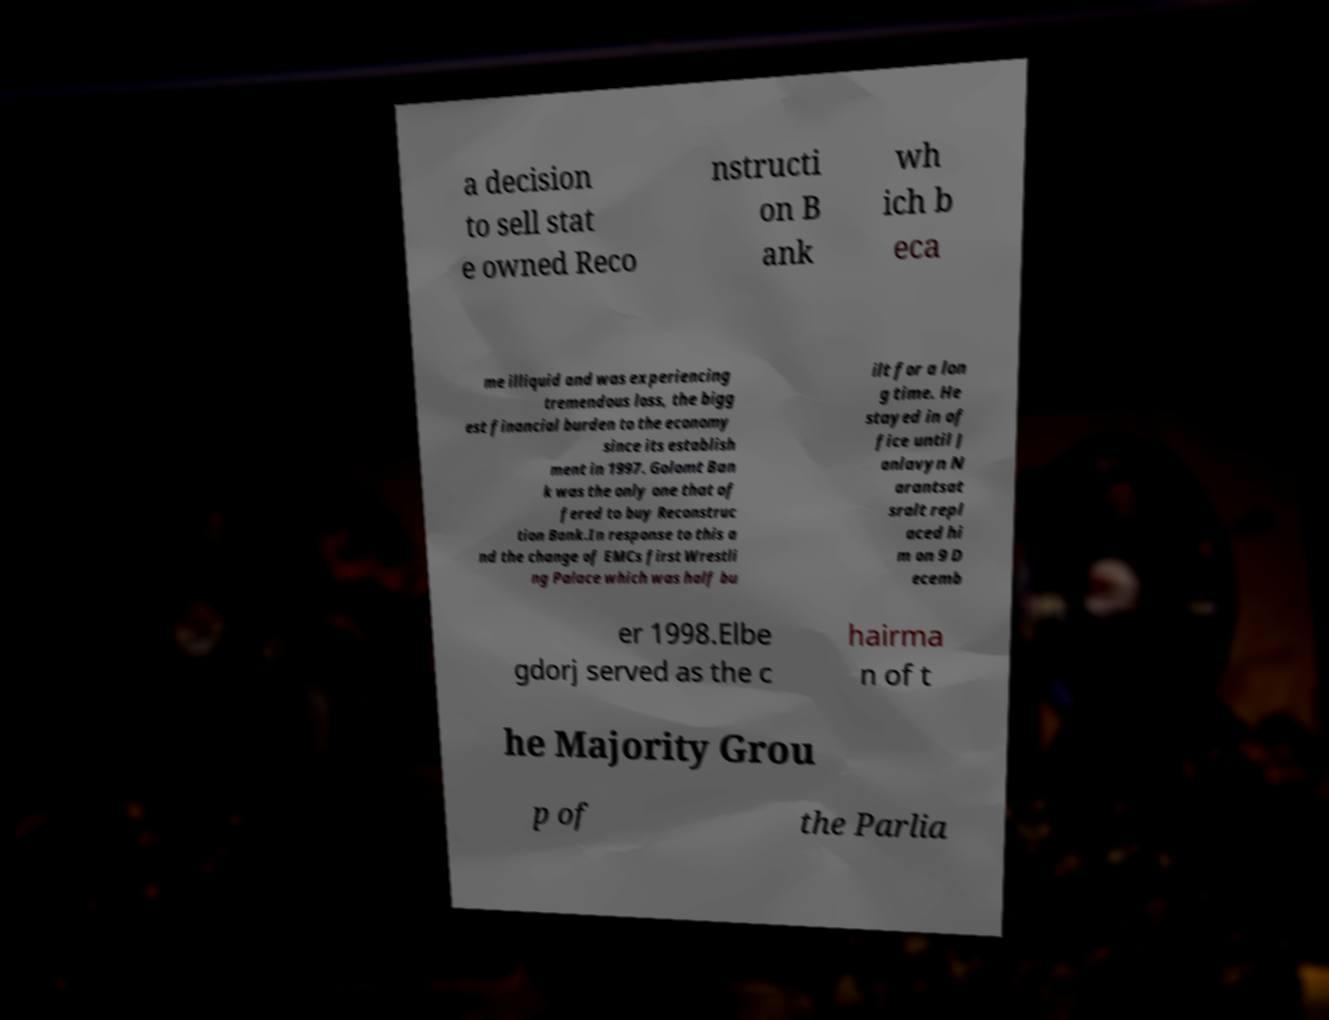I need the written content from this picture converted into text. Can you do that? a decision to sell stat e owned Reco nstructi on B ank wh ich b eca me illiquid and was experiencing tremendous loss, the bigg est financial burden to the economy since its establish ment in 1997. Golomt Ban k was the only one that of fered to buy Reconstruc tion Bank.In response to this a nd the change of EMCs first Wrestli ng Palace which was half bu ilt for a lon g time. He stayed in of fice until J anlavyn N arantsat sralt repl aced hi m on 9 D ecemb er 1998.Elbe gdorj served as the c hairma n of t he Majority Grou p of the Parlia 